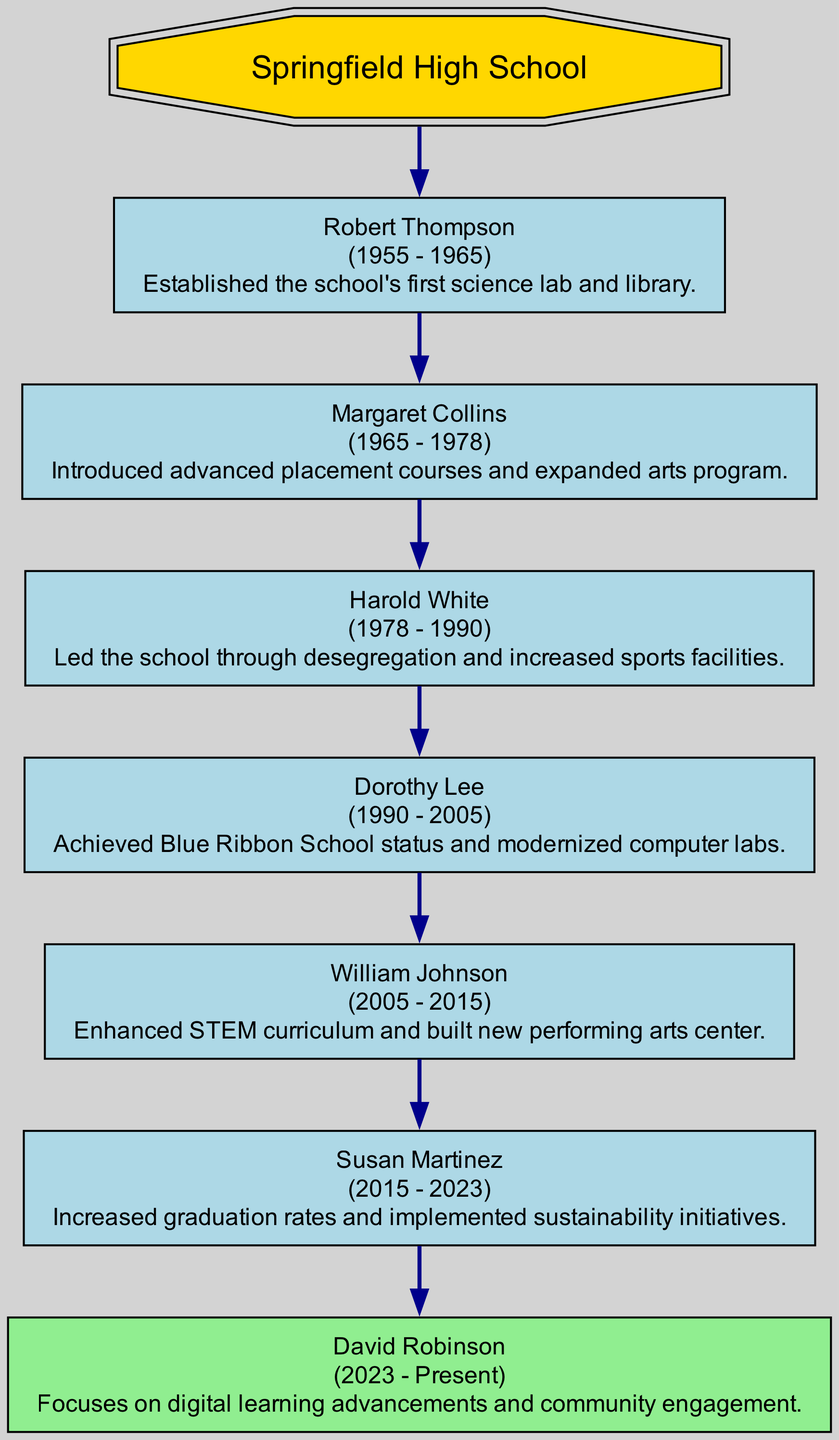What is the name of the current principal? The current principal is indicated in the diagram's last node as "David Robinson."
Answer: David Robinson How long did Margaret Collins serve as principal? By looking at her node, her term is marked from 1965 to 1978, which amounts to 13 years.
Answer: 13 years What major achievement is associated with Harold White? The diagram shows that his major achievement involved desegregation and increased sports facilities, as stated in his node.
Answer: Desegregation and increased sports facilities Who was the principal before Susan Martinez? To find this, we look at the node just prior to hers in the diagram, which is "William Johnson."
Answer: William Johnson What year did Robert Thompson's term end? The specific node detailing his term shows it ended in 1965.
Answer: 1965 How many principals served from 1955 to 2005? Count the nodes from "Robert Thompson," starting from 1955 up to "Dorothy Lee" who ended in 2005; there are five principals in total during this timeframe.
Answer: 5 Who introduced advanced placement courses? The node associated with Margaret Collins lists her major achievements, where "advanced placement courses" is mentioned prominently.
Answer: Margaret Collins Which achievement is listed for the current principal? The current principal's node highlights "digital learning advancements and community engagement."
Answer: Digital learning advancements and community engagement In what year did William Johnson begin his term? Looking at William Johnson's node, he started his term in 2005, as indicated.
Answer: 2005 